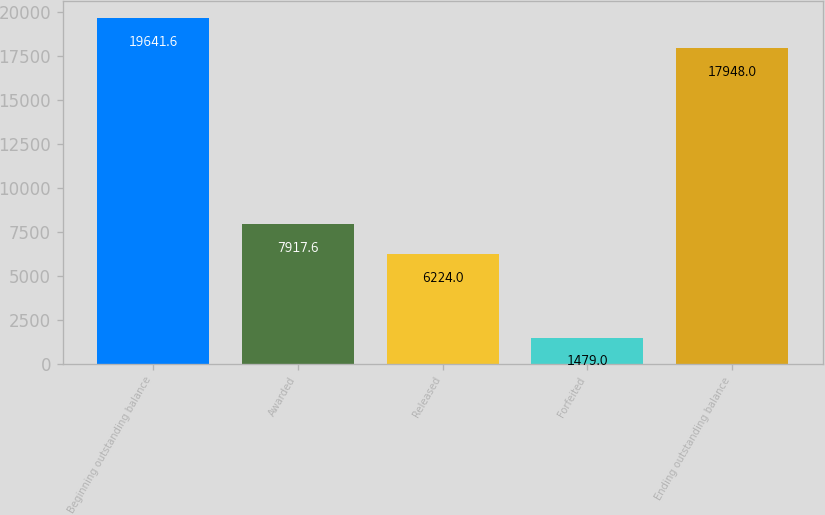Convert chart to OTSL. <chart><loc_0><loc_0><loc_500><loc_500><bar_chart><fcel>Beginning outstanding balance<fcel>Awarded<fcel>Released<fcel>Forfeited<fcel>Ending outstanding balance<nl><fcel>19641.6<fcel>7917.6<fcel>6224<fcel>1479<fcel>17948<nl></chart> 